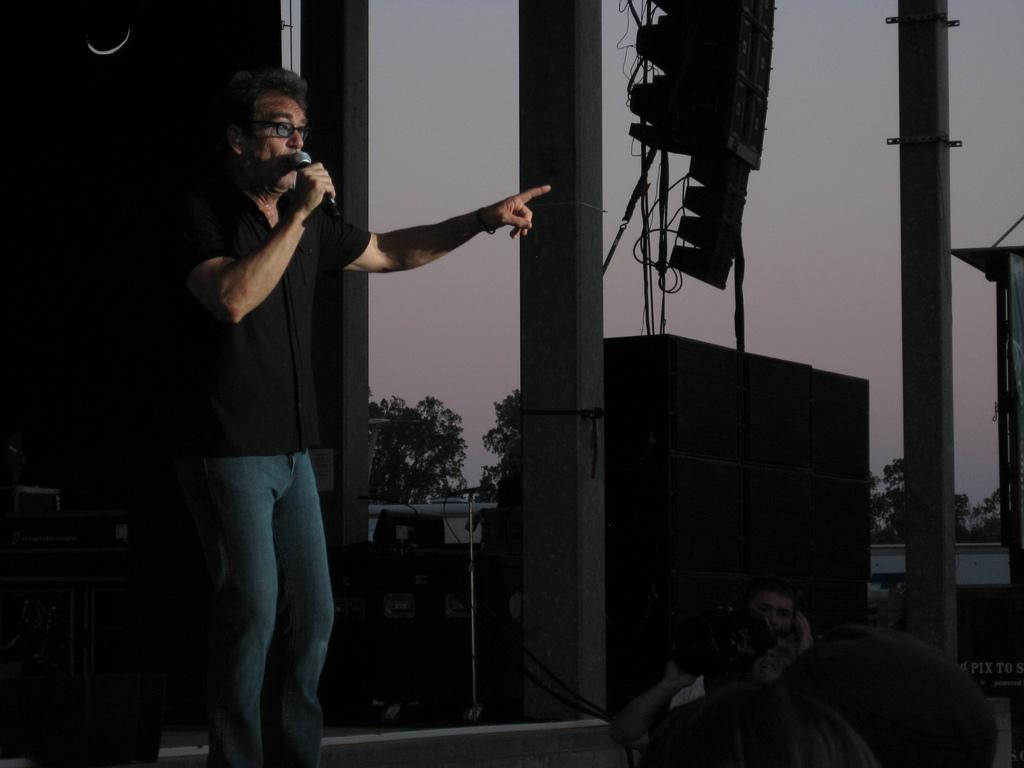What is the man in the foreground of the image doing? The man in the foreground is standing and holding a mic. What is the man in the background of the image doing? The man in the background is holding a camera. What can be seen in the background of the image? There are trees in the background of the image. Where is the aunt sitting with her kitty in the image? There is no aunt or kitty present in the image. What type of wall can be seen in the image? There is no wall visible in the image. 